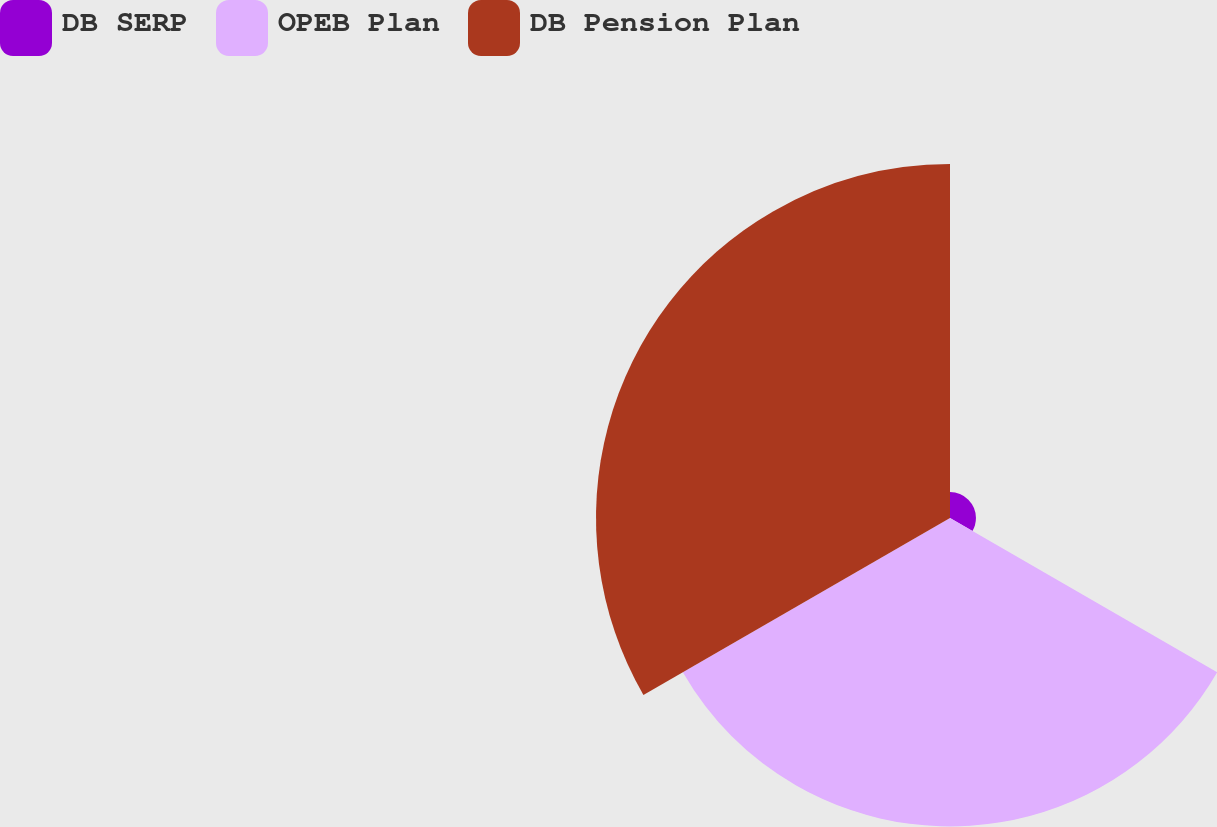Convert chart to OTSL. <chart><loc_0><loc_0><loc_500><loc_500><pie_chart><fcel>DB SERP<fcel>OPEB Plan<fcel>DB Pension Plan<nl><fcel>3.77%<fcel>44.81%<fcel>51.42%<nl></chart> 